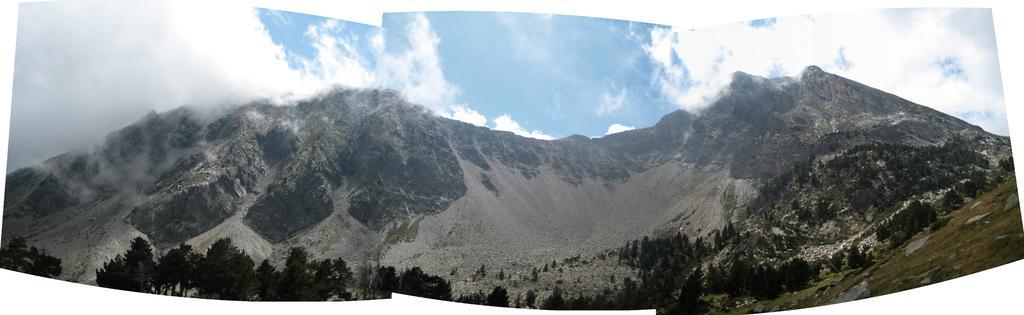Describe this image in one or two sentences. In this image there are trees and mountains, at the top of the image there are clouds in the sky. 